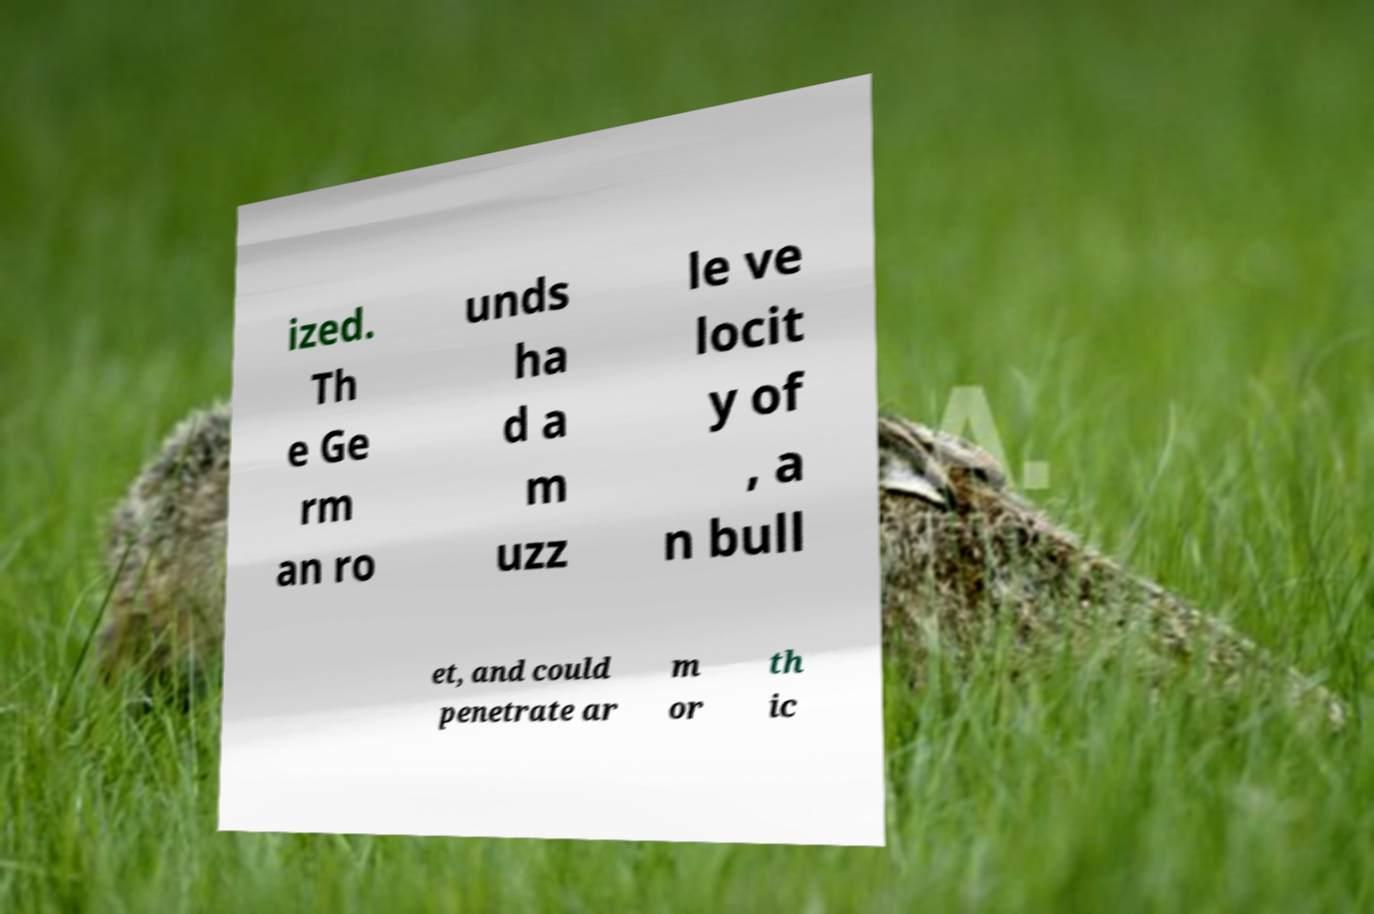Could you extract and type out the text from this image? ized. Th e Ge rm an ro unds ha d a m uzz le ve locit y of , a n bull et, and could penetrate ar m or th ic 